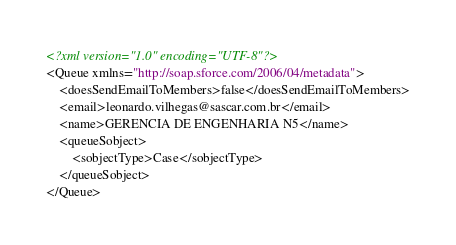Convert code to text. <code><loc_0><loc_0><loc_500><loc_500><_XML_><?xml version="1.0" encoding="UTF-8"?>
<Queue xmlns="http://soap.sforce.com/2006/04/metadata">
    <doesSendEmailToMembers>false</doesSendEmailToMembers>
    <email>leonardo.vilhegas@sascar.com.br</email>
    <name>GERENCIA DE ENGENHARIA N5</name>
    <queueSobject>
        <sobjectType>Case</sobjectType>
    </queueSobject>
</Queue>
</code> 